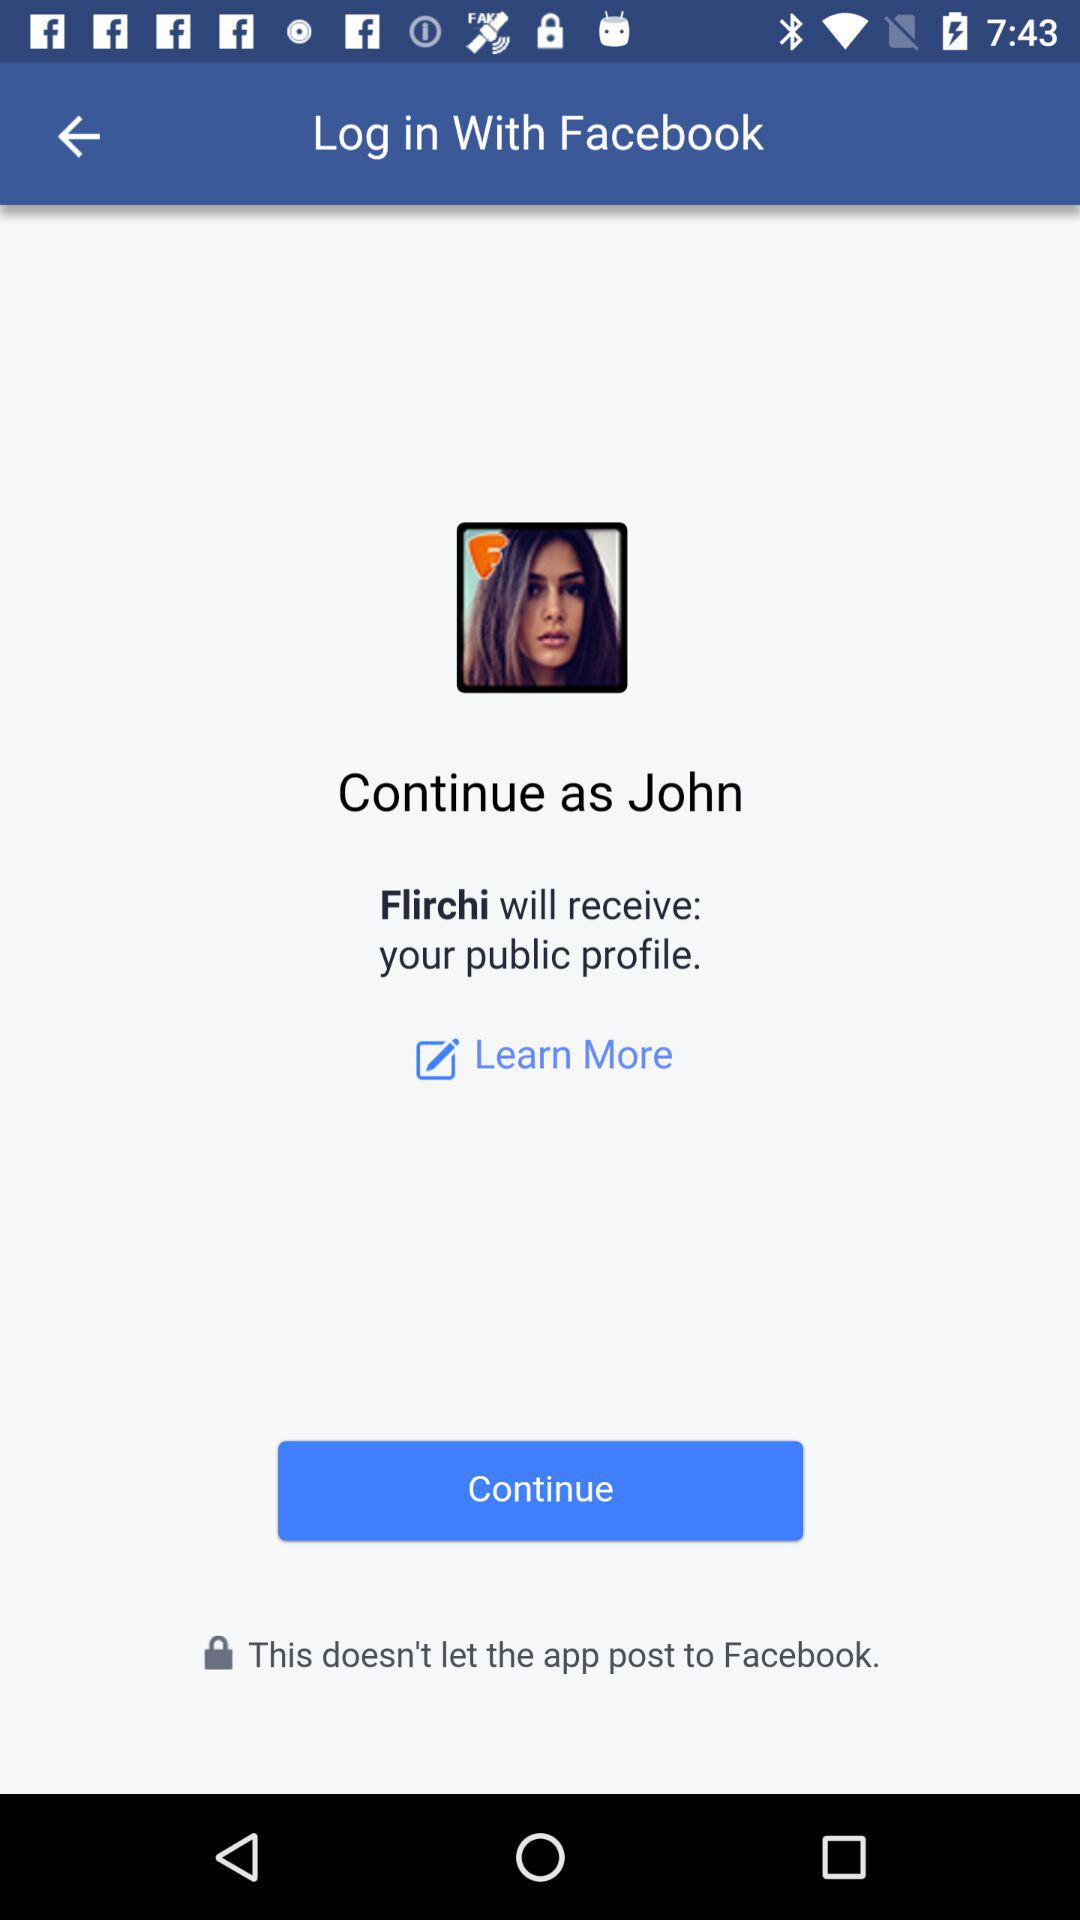What account am I using to log in? You are using "Facebook" to log in. 